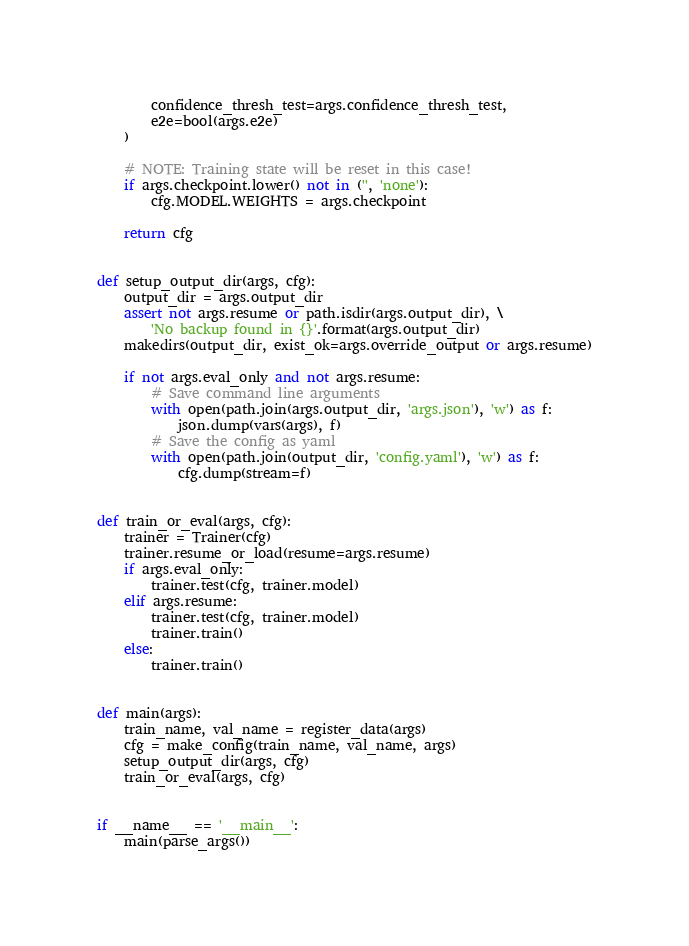Convert code to text. <code><loc_0><loc_0><loc_500><loc_500><_Python_>        confidence_thresh_test=args.confidence_thresh_test,
        e2e=bool(args.e2e)
    )

    # NOTE: Training state will be reset in this case!
    if args.checkpoint.lower() not in ('', 'none'):
        cfg.MODEL.WEIGHTS = args.checkpoint

    return cfg


def setup_output_dir(args, cfg):
    output_dir = args.output_dir
    assert not args.resume or path.isdir(args.output_dir), \
        'No backup found in {}'.format(args.output_dir)
    makedirs(output_dir, exist_ok=args.override_output or args.resume)

    if not args.eval_only and not args.resume:
        # Save command line arguments
        with open(path.join(args.output_dir, 'args.json'), 'w') as f:
            json.dump(vars(args), f)
        # Save the config as yaml
        with open(path.join(output_dir, 'config.yaml'), 'w') as f:
            cfg.dump(stream=f)


def train_or_eval(args, cfg):
    trainer = Trainer(cfg)
    trainer.resume_or_load(resume=args.resume)
    if args.eval_only:
        trainer.test(cfg, trainer.model)
    elif args.resume:
        trainer.test(cfg, trainer.model)
        trainer.train()
    else:
        trainer.train()


def main(args):
    train_name, val_name = register_data(args)
    cfg = make_config(train_name, val_name, args)
    setup_output_dir(args, cfg)
    train_or_eval(args, cfg)


if __name__ == '__main__':
    main(parse_args())
</code> 